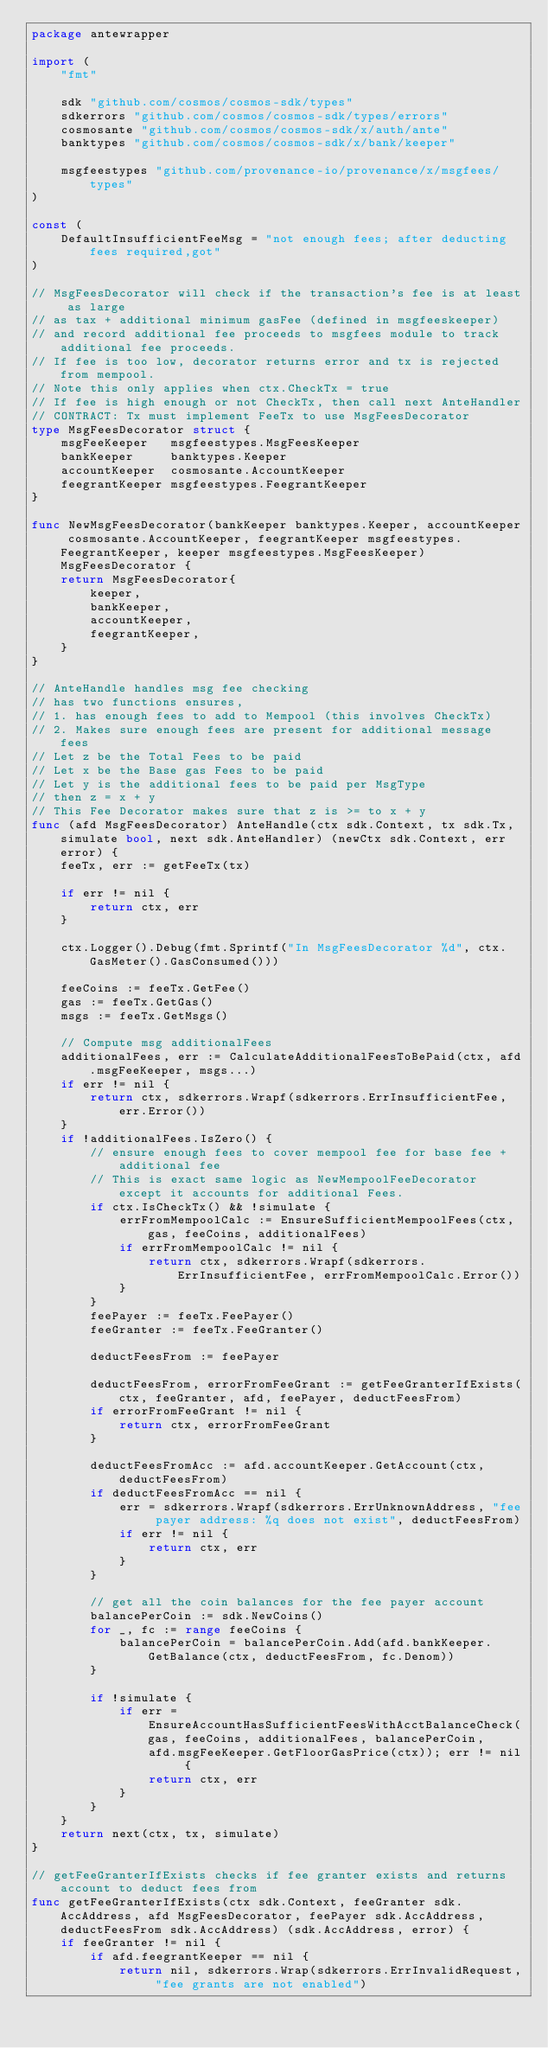<code> <loc_0><loc_0><loc_500><loc_500><_Go_>package antewrapper

import (
	"fmt"

	sdk "github.com/cosmos/cosmos-sdk/types"
	sdkerrors "github.com/cosmos/cosmos-sdk/types/errors"
	cosmosante "github.com/cosmos/cosmos-sdk/x/auth/ante"
	banktypes "github.com/cosmos/cosmos-sdk/x/bank/keeper"

	msgfeestypes "github.com/provenance-io/provenance/x/msgfees/types"
)

const (
	DefaultInsufficientFeeMsg = "not enough fees; after deducting fees required,got"
)

// MsgFeesDecorator will check if the transaction's fee is at least as large
// as tax + additional minimum gasFee (defined in msgfeeskeeper)
// and record additional fee proceeds to msgfees module to track additional fee proceeds.
// If fee is too low, decorator returns error and tx is rejected from mempool.
// Note this only applies when ctx.CheckTx = true
// If fee is high enough or not CheckTx, then call next AnteHandler
// CONTRACT: Tx must implement FeeTx to use MsgFeesDecorator
type MsgFeesDecorator struct {
	msgFeeKeeper   msgfeestypes.MsgFeesKeeper
	bankKeeper     banktypes.Keeper
	accountKeeper  cosmosante.AccountKeeper
	feegrantKeeper msgfeestypes.FeegrantKeeper
}

func NewMsgFeesDecorator(bankKeeper banktypes.Keeper, accountKeeper cosmosante.AccountKeeper, feegrantKeeper msgfeestypes.FeegrantKeeper, keeper msgfeestypes.MsgFeesKeeper) MsgFeesDecorator {
	return MsgFeesDecorator{
		keeper,
		bankKeeper,
		accountKeeper,
		feegrantKeeper,
	}
}

// AnteHandle handles msg fee checking
// has two functions ensures,
// 1. has enough fees to add to Mempool (this involves CheckTx)
// 2. Makes sure enough fees are present for additional message fees
// Let z be the Total Fees to be paid
// Let x be the Base gas Fees to be paid
// Let y is the additional fees to be paid per MsgType
// then z = x + y
// This Fee Decorator makes sure that z is >= to x + y
func (afd MsgFeesDecorator) AnteHandle(ctx sdk.Context, tx sdk.Tx, simulate bool, next sdk.AnteHandler) (newCtx sdk.Context, err error) {
	feeTx, err := getFeeTx(tx)

	if err != nil {
		return ctx, err
	}

	ctx.Logger().Debug(fmt.Sprintf("In MsgFeesDecorator %d", ctx.GasMeter().GasConsumed()))

	feeCoins := feeTx.GetFee()
	gas := feeTx.GetGas()
	msgs := feeTx.GetMsgs()

	// Compute msg additionalFees
	additionalFees, err := CalculateAdditionalFeesToBePaid(ctx, afd.msgFeeKeeper, msgs...)
	if err != nil {
		return ctx, sdkerrors.Wrapf(sdkerrors.ErrInsufficientFee, err.Error())
	}
	if !additionalFees.IsZero() {
		// ensure enough fees to cover mempool fee for base fee + additional fee
		// This is exact same logic as NewMempoolFeeDecorator except it accounts for additional Fees.
		if ctx.IsCheckTx() && !simulate {
			errFromMempoolCalc := EnsureSufficientMempoolFees(ctx, gas, feeCoins, additionalFees)
			if errFromMempoolCalc != nil {
				return ctx, sdkerrors.Wrapf(sdkerrors.ErrInsufficientFee, errFromMempoolCalc.Error())
			}
		}
		feePayer := feeTx.FeePayer()
		feeGranter := feeTx.FeeGranter()

		deductFeesFrom := feePayer

		deductFeesFrom, errorFromFeeGrant := getFeeGranterIfExists(ctx, feeGranter, afd, feePayer, deductFeesFrom)
		if errorFromFeeGrant != nil {
			return ctx, errorFromFeeGrant
		}

		deductFeesFromAcc := afd.accountKeeper.GetAccount(ctx, deductFeesFrom)
		if deductFeesFromAcc == nil {
			err = sdkerrors.Wrapf(sdkerrors.ErrUnknownAddress, "fee payer address: %q does not exist", deductFeesFrom)
			if err != nil {
				return ctx, err
			}
		}

		// get all the coin balances for the fee payer account
		balancePerCoin := sdk.NewCoins()
		for _, fc := range feeCoins {
			balancePerCoin = balancePerCoin.Add(afd.bankKeeper.GetBalance(ctx, deductFeesFrom, fc.Denom))
		}

		if !simulate {
			if err = EnsureAccountHasSufficientFeesWithAcctBalanceCheck(gas, feeCoins, additionalFees, balancePerCoin,
				afd.msgFeeKeeper.GetFloorGasPrice(ctx)); err != nil {
				return ctx, err
			}
		}
	}
	return next(ctx, tx, simulate)
}

// getFeeGranterIfExists checks if fee granter exists and returns account to deduct fees from
func getFeeGranterIfExists(ctx sdk.Context, feeGranter sdk.AccAddress, afd MsgFeesDecorator, feePayer sdk.AccAddress, deductFeesFrom sdk.AccAddress) (sdk.AccAddress, error) {
	if feeGranter != nil {
		if afd.feegrantKeeper == nil {
			return nil, sdkerrors.Wrap(sdkerrors.ErrInvalidRequest, "fee grants are not enabled")</code> 